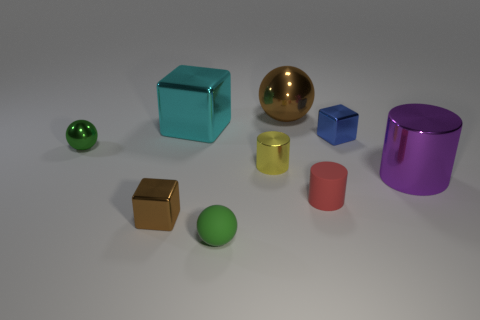Subtract all metallic cylinders. How many cylinders are left? 1 Add 1 big red spheres. How many objects exist? 10 Subtract all cubes. How many objects are left? 6 Subtract 0 gray cylinders. How many objects are left? 9 Subtract all cyan shiny objects. Subtract all tiny yellow matte cylinders. How many objects are left? 8 Add 6 brown things. How many brown things are left? 8 Add 3 tiny gray metallic cylinders. How many tiny gray metallic cylinders exist? 3 